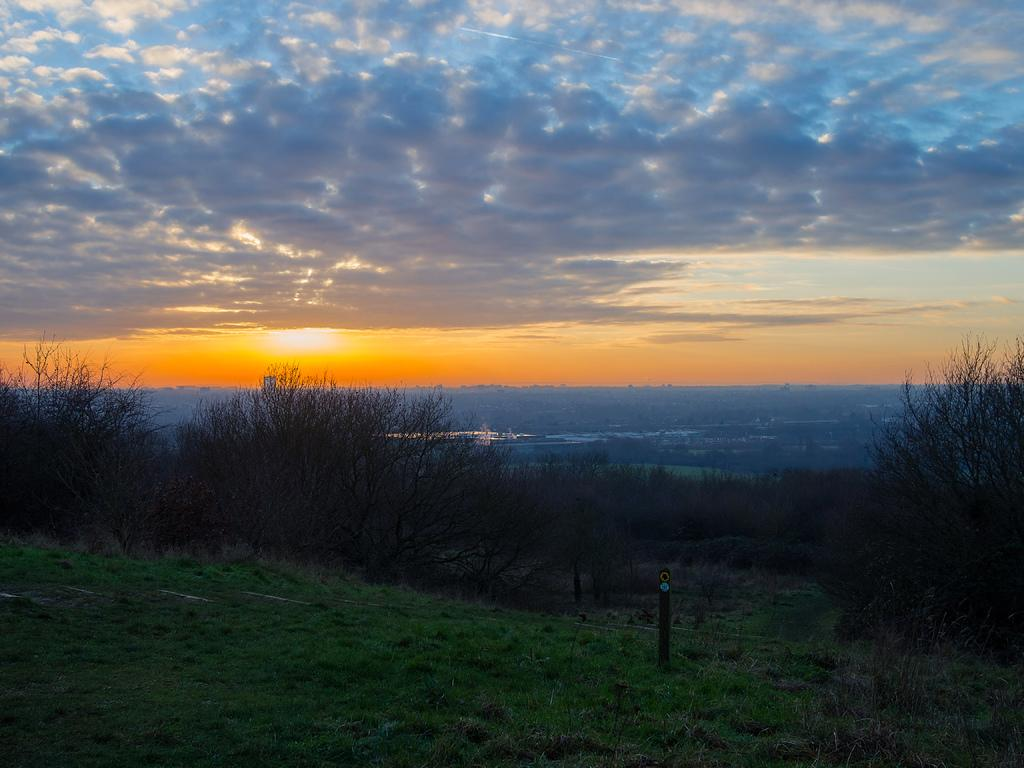What type of vegetation is at the bottom of the image? There is grass at the bottom of the image. What structure can be seen in the image? There is a pole in the image. What other natural elements are present in the image? There are trees in the image. What can be seen in the background of the image? The sky is visible in the background of the image. What celestial body and weather phenomenon are present in the sky? The sun is present in the sky, and there are clouds as well. Can you describe the woman carrying a loaf of bread in the image? There is no woman carrying a loaf of bread present in the image. What type of basket is hanging from the pole in the image? There is no basket hanging from the pole in the image. 